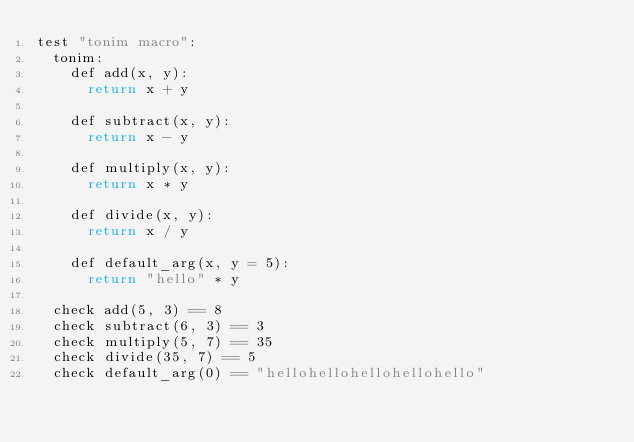<code> <loc_0><loc_0><loc_500><loc_500><_Nim_>test "tonim macro":
  tonim:
    def add(x, y):
      return x + y
    
    def subtract(x, y):
      return x - y

    def multiply(x, y):
      return x * y

    def divide(x, y):
      return x / y
    
    def default_arg(x, y = 5):
      return "hello" * y

  check add(5, 3) == 8
  check subtract(6, 3) == 3
  check multiply(5, 7) == 35
  check divide(35, 7) == 5
  check default_arg(0) == "hellohellohellohellohello"

</code> 